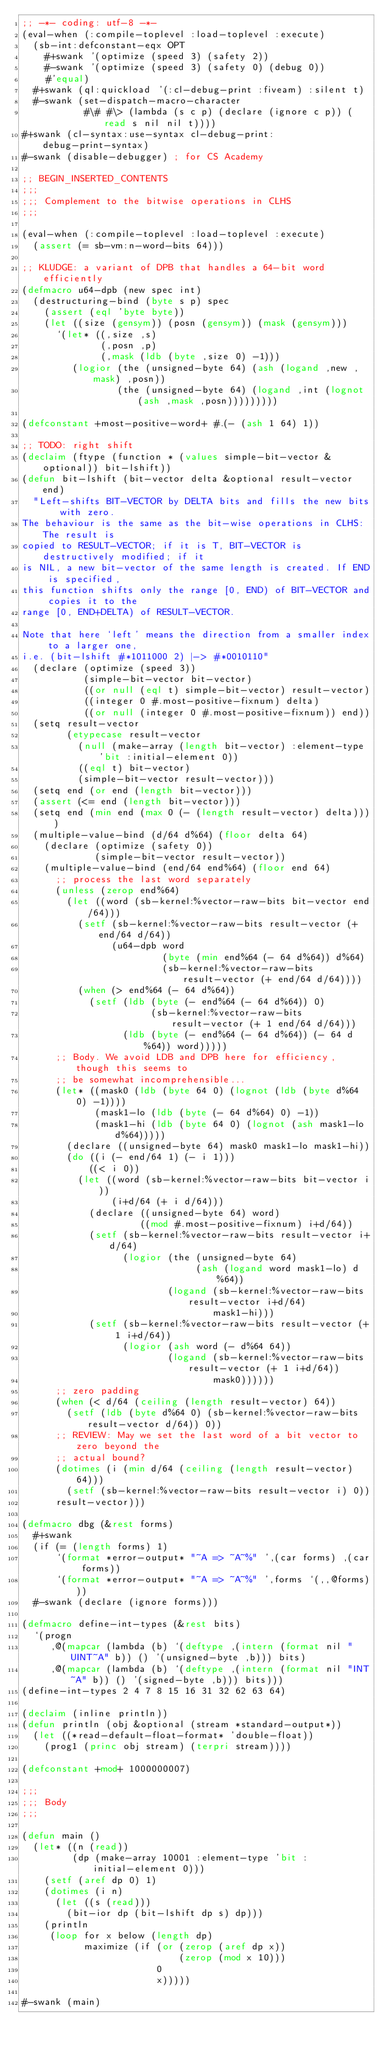<code> <loc_0><loc_0><loc_500><loc_500><_Lisp_>;; -*- coding: utf-8 -*-
(eval-when (:compile-toplevel :load-toplevel :execute)
  (sb-int:defconstant-eqx OPT
    #+swank '(optimize (speed 3) (safety 2))
    #-swank '(optimize (speed 3) (safety 0) (debug 0))
    #'equal)
  #+swank (ql:quickload '(:cl-debug-print :fiveam) :silent t)
  #-swank (set-dispatch-macro-character
           #\# #\> (lambda (s c p) (declare (ignore c p)) (read s nil nil t))))
#+swank (cl-syntax:use-syntax cl-debug-print:debug-print-syntax)
#-swank (disable-debugger) ; for CS Academy

;; BEGIN_INSERTED_CONTENTS
;;;
;;; Complement to the bitwise operations in CLHS
;;;

(eval-when (:compile-toplevel :load-toplevel :execute)
  (assert (= sb-vm:n-word-bits 64)))

;; KLUDGE: a variant of DPB that handles a 64-bit word efficiently
(defmacro u64-dpb (new spec int)
  (destructuring-bind (byte s p) spec
    (assert (eql 'byte byte))
    (let ((size (gensym)) (posn (gensym)) (mask (gensym)))
      `(let* ((,size ,s)
              (,posn ,p)
              (,mask (ldb (byte ,size 0) -1)))
         (logior (the (unsigned-byte 64) (ash (logand ,new ,mask) ,posn))
                 (the (unsigned-byte 64) (logand ,int (lognot (ash ,mask ,posn)))))))))

(defconstant +most-positive-word+ #.(- (ash 1 64) 1))

;; TODO: right shift
(declaim (ftype (function * (values simple-bit-vector &optional)) bit-lshift))
(defun bit-lshift (bit-vector delta &optional result-vector end)
  "Left-shifts BIT-VECTOR by DELTA bits and fills the new bits with zero.
The behaviour is the same as the bit-wise operations in CLHS: The result is
copied to RESULT-VECTOR; if it is T, BIT-VECTOR is destructively modified; if it
is NIL, a new bit-vector of the same length is created. If END is specified,
this function shifts only the range [0, END) of BIT-VECTOR and copies it to the
range [0, END+DELTA) of RESULT-VECTOR.

Note that here `left' means the direction from a smaller index to a larger one,
i.e. (bit-lshift #*1011000 2) |-> #*0010110"
  (declare (optimize (speed 3))
           (simple-bit-vector bit-vector)
           ((or null (eql t) simple-bit-vector) result-vector)
           ((integer 0 #.most-positive-fixnum) delta)
           ((or null (integer 0 #.most-positive-fixnum)) end))
  (setq result-vector
        (etypecase result-vector
          (null (make-array (length bit-vector) :element-type 'bit :initial-element 0))
          ((eql t) bit-vector)
          (simple-bit-vector result-vector)))
  (setq end (or end (length bit-vector)))
  (assert (<= end (length bit-vector)))
  (setq end (min end (max 0 (- (length result-vector) delta))))
  (multiple-value-bind (d/64 d%64) (floor delta 64)
    (declare (optimize (safety 0))
             (simple-bit-vector result-vector))
    (multiple-value-bind (end/64 end%64) (floor end 64)
      ;; process the last word separately
      (unless (zerop end%64)
        (let ((word (sb-kernel:%vector-raw-bits bit-vector end/64)))
          (setf (sb-kernel:%vector-raw-bits result-vector (+ end/64 d/64))
                (u64-dpb word
                         (byte (min end%64 (- 64 d%64)) d%64)
                         (sb-kernel:%vector-raw-bits result-vector (+ end/64 d/64))))
          (when (> end%64 (- 64 d%64))
            (setf (ldb (byte (- end%64 (- 64 d%64)) 0)
                       (sb-kernel:%vector-raw-bits result-vector (+ 1 end/64 d/64)))
                  (ldb (byte (- end%64 (- 64 d%64)) (- 64 d%64)) word)))))
      ;; Body. We avoid LDB and DPB here for efficiency, though this seems to
      ;; be somewhat incomprehensible...
      (let* ((mask0 (ldb (byte 64 0) (lognot (ldb (byte d%64 0) -1))))
             (mask1-lo (ldb (byte (- 64 d%64) 0) -1))
             (mask1-hi (ldb (byte 64 0) (lognot (ash mask1-lo d%64)))))
        (declare ((unsigned-byte 64) mask0 mask1-lo mask1-hi))
        (do ((i (- end/64 1) (- i 1)))
            ((< i 0))
          (let ((word (sb-kernel:%vector-raw-bits bit-vector i))
                (i+d/64 (+ i d/64)))
            (declare ((unsigned-byte 64) word)
                     ((mod #.most-positive-fixnum) i+d/64))
            (setf (sb-kernel:%vector-raw-bits result-vector i+d/64)
                  (logior (the (unsigned-byte 64)
                               (ash (logand word mask1-lo) d%64))
                          (logand (sb-kernel:%vector-raw-bits result-vector i+d/64)
                                  mask1-hi)))
            (setf (sb-kernel:%vector-raw-bits result-vector (+ 1 i+d/64))
                  (logior (ash word (- d%64 64))
                          (logand (sb-kernel:%vector-raw-bits result-vector (+ 1 i+d/64))
                                  mask0))))))
      ;; zero padding
      (when (< d/64 (ceiling (length result-vector) 64))
        (setf (ldb (byte d%64 0) (sb-kernel:%vector-raw-bits result-vector d/64)) 0))
      ;; REVIEW: May we set the last word of a bit vector to zero beyond the
      ;; actual bound?
      (dotimes (i (min d/64 (ceiling (length result-vector) 64)))
        (setf (sb-kernel:%vector-raw-bits result-vector i) 0))
      result-vector)))

(defmacro dbg (&rest forms)
  #+swank
  (if (= (length forms) 1)
      `(format *error-output* "~A => ~A~%" ',(car forms) ,(car forms))
      `(format *error-output* "~A => ~A~%" ',forms `(,,@forms)))
  #-swank (declare (ignore forms)))

(defmacro define-int-types (&rest bits)
  `(progn
     ,@(mapcar (lambda (b) `(deftype ,(intern (format nil "UINT~A" b)) () '(unsigned-byte ,b))) bits)
     ,@(mapcar (lambda (b) `(deftype ,(intern (format nil "INT~A" b)) () '(signed-byte ,b))) bits)))
(define-int-types 2 4 7 8 15 16 31 32 62 63 64)

(declaim (inline println))
(defun println (obj &optional (stream *standard-output*))
  (let ((*read-default-float-format* 'double-float))
    (prog1 (princ obj stream) (terpri stream))))

(defconstant +mod+ 1000000007)

;;;
;;; Body
;;;

(defun main ()
  (let* ((n (read))
         (dp (make-array 10001 :element-type 'bit :initial-element 0)))
    (setf (aref dp 0) 1)
    (dotimes (i n)
      (let ((s (read)))
        (bit-ior dp (bit-lshift dp s) dp)))
    (println
     (loop for x below (length dp)
           maximize (if (or (zerop (aref dp x))
                            (zerop (mod x 10)))
                        0
                        x)))))

#-swank (main)
</code> 